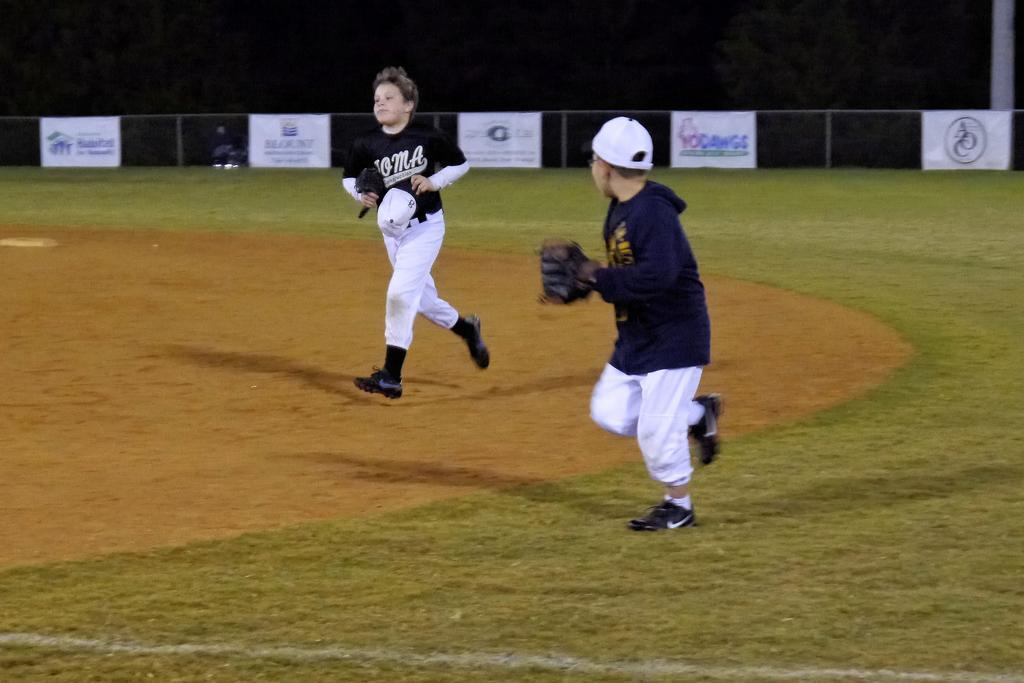Can you describe this image briefly? In this picture I can see the ground on which I can see 2 boys, who are jerseys and in the background I can see the fencing on which there are banners and I see something is written on it. On the top of this picture I see that it is dark. On the top right corner I can see a pole. On the bottom of this picture I can see a white line. 